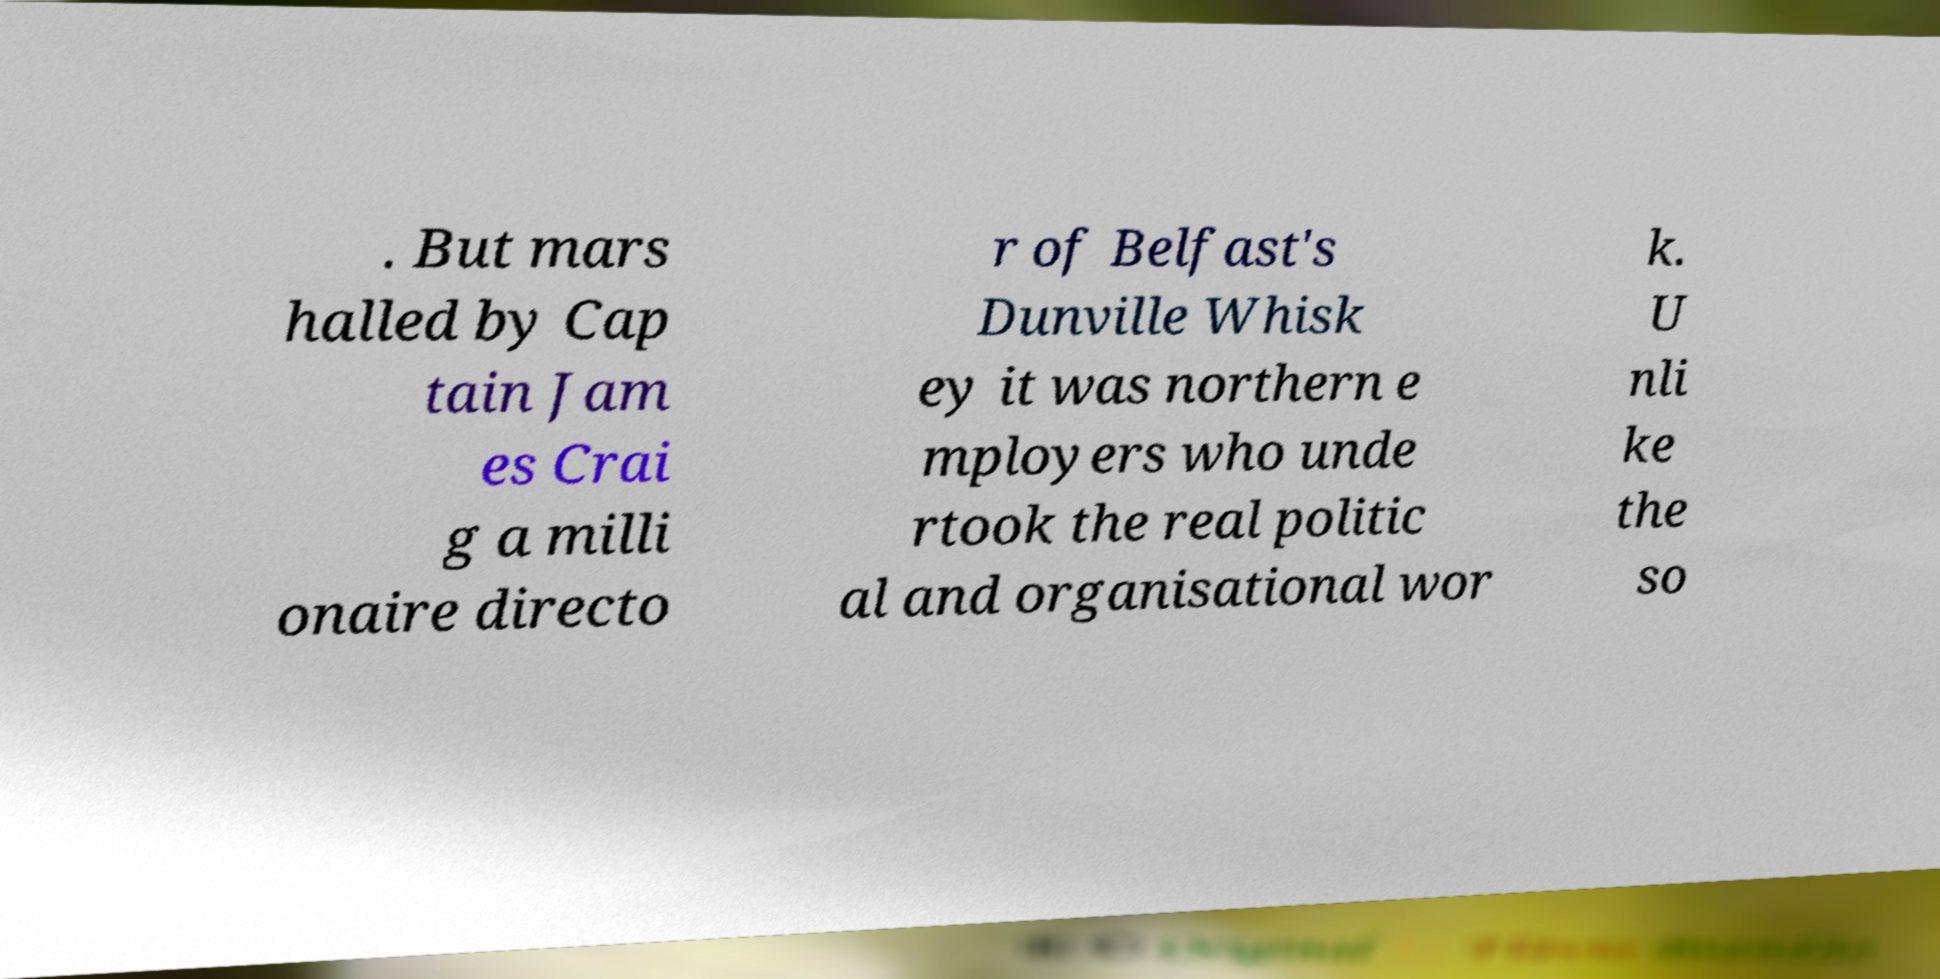Could you extract and type out the text from this image? . But mars halled by Cap tain Jam es Crai g a milli onaire directo r of Belfast's Dunville Whisk ey it was northern e mployers who unde rtook the real politic al and organisational wor k. U nli ke the so 